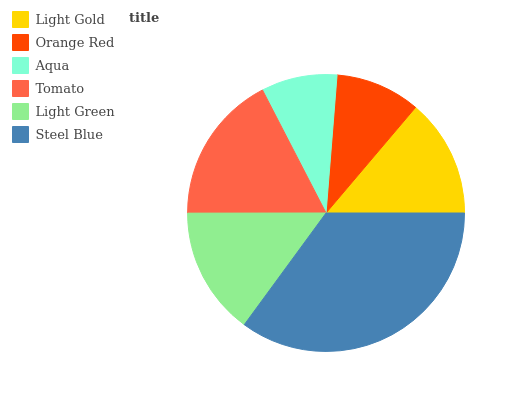Is Aqua the minimum?
Answer yes or no. Yes. Is Steel Blue the maximum?
Answer yes or no. Yes. Is Orange Red the minimum?
Answer yes or no. No. Is Orange Red the maximum?
Answer yes or no. No. Is Light Gold greater than Orange Red?
Answer yes or no. Yes. Is Orange Red less than Light Gold?
Answer yes or no. Yes. Is Orange Red greater than Light Gold?
Answer yes or no. No. Is Light Gold less than Orange Red?
Answer yes or no. No. Is Light Green the high median?
Answer yes or no. Yes. Is Light Gold the low median?
Answer yes or no. Yes. Is Steel Blue the high median?
Answer yes or no. No. Is Light Green the low median?
Answer yes or no. No. 